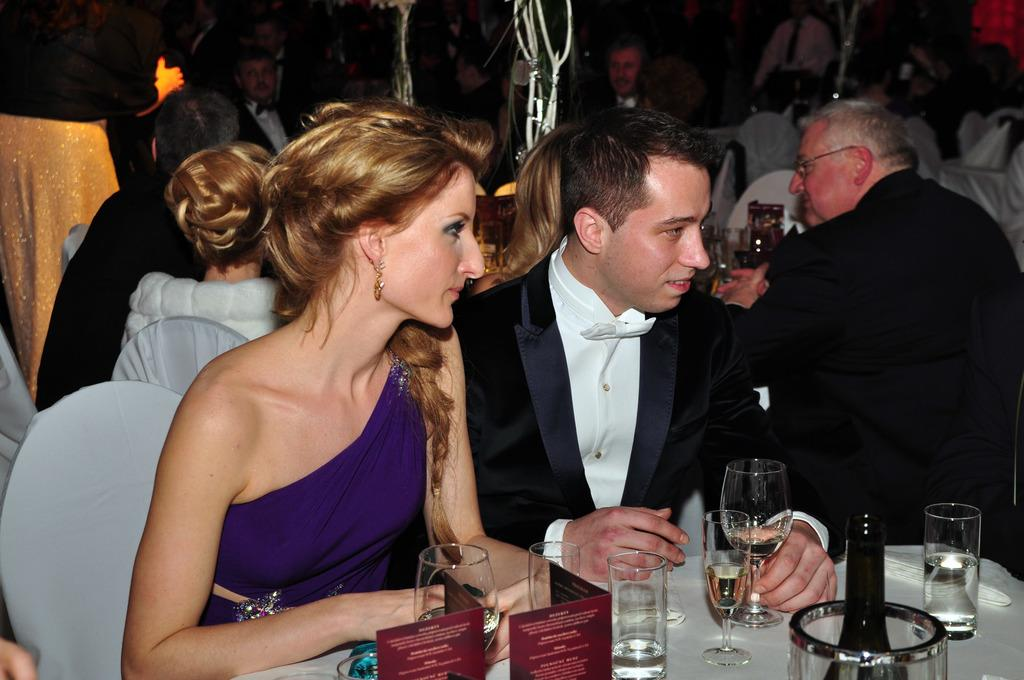What is the main subject of the image? The main subject of the image is a group of people. What are the people doing in the image? The people are sitting on chairs in the image. What objects can be seen on the table in the image? There is a glass, a bottle, and a card on the table in the image. What type of stone is being rolled across the table in the image? There is no stone present in the image, and no rolling action is taking place. 